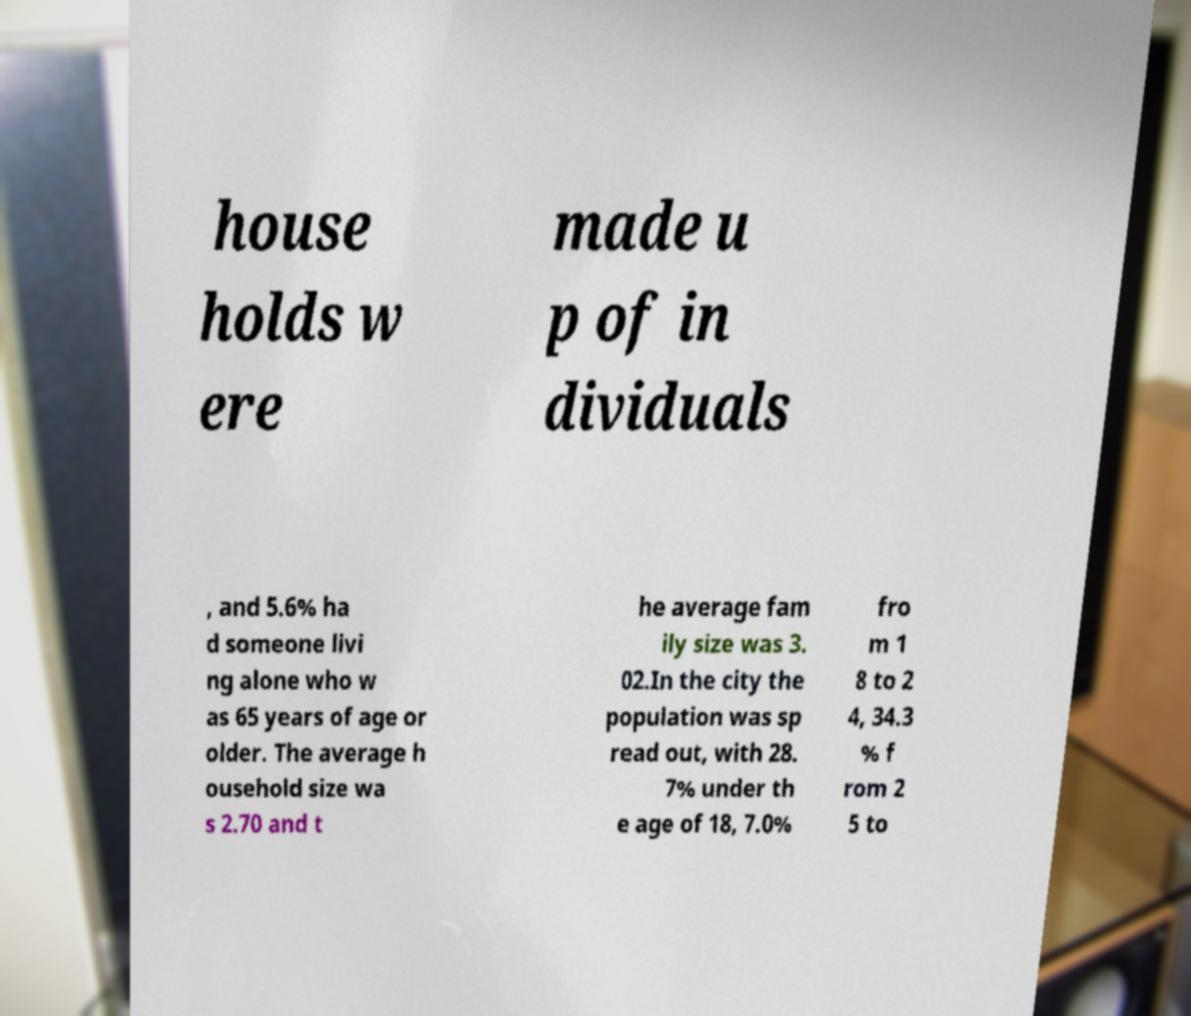I need the written content from this picture converted into text. Can you do that? house holds w ere made u p of in dividuals , and 5.6% ha d someone livi ng alone who w as 65 years of age or older. The average h ousehold size wa s 2.70 and t he average fam ily size was 3. 02.In the city the population was sp read out, with 28. 7% under th e age of 18, 7.0% fro m 1 8 to 2 4, 34.3 % f rom 2 5 to 